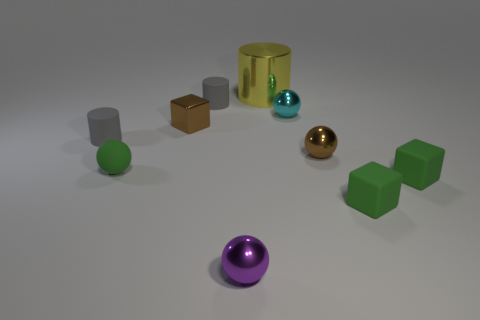What material is the cyan sphere that is the same size as the metallic cube?
Make the answer very short. Metal. The tiny metal object that is both behind the tiny brown metallic ball and to the right of the small purple shiny sphere is what color?
Keep it short and to the point. Cyan. Does the shiny object on the right side of the cyan thing have the same color as the tiny shiny cube?
Make the answer very short. Yes. The purple thing that is the same size as the cyan metallic ball is what shape?
Offer a terse response. Sphere. How many other things are there of the same color as the rubber sphere?
Give a very brief answer. 2. What number of other objects are there of the same material as the purple ball?
Ensure brevity in your answer.  4. Do the purple metal thing and the gray cylinder to the right of the brown cube have the same size?
Ensure brevity in your answer.  Yes. What color is the metal cylinder?
Give a very brief answer. Yellow. What shape is the small gray thing that is on the right side of the small green object on the left side of the brown metal object that is left of the purple object?
Provide a short and direct response. Cylinder. What is the material of the small sphere that is left of the tiny gray rubber thing behind the tiny cyan metallic ball?
Your answer should be compact. Rubber. 